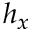Convert formula to latex. <formula><loc_0><loc_0><loc_500><loc_500>h _ { x }</formula> 